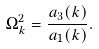<formula> <loc_0><loc_0><loc_500><loc_500>\Omega _ { k } ^ { 2 } = \frac { a _ { 3 } ( { k } ) } { a _ { 1 } ( { k } ) } .</formula> 